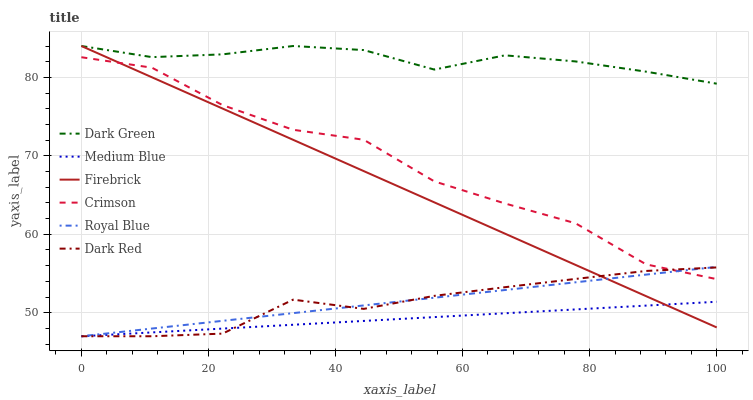Does Medium Blue have the minimum area under the curve?
Answer yes or no. Yes. Does Dark Green have the maximum area under the curve?
Answer yes or no. Yes. Does Firebrick have the minimum area under the curve?
Answer yes or no. No. Does Firebrick have the maximum area under the curve?
Answer yes or no. No. Is Firebrick the smoothest?
Answer yes or no. Yes. Is Crimson the roughest?
Answer yes or no. Yes. Is Medium Blue the smoothest?
Answer yes or no. No. Is Medium Blue the roughest?
Answer yes or no. No. Does Dark Red have the lowest value?
Answer yes or no. Yes. Does Firebrick have the lowest value?
Answer yes or no. No. Does Dark Green have the highest value?
Answer yes or no. Yes. Does Medium Blue have the highest value?
Answer yes or no. No. Is Medium Blue less than Crimson?
Answer yes or no. Yes. Is Dark Green greater than Crimson?
Answer yes or no. Yes. Does Dark Red intersect Crimson?
Answer yes or no. Yes. Is Dark Red less than Crimson?
Answer yes or no. No. Is Dark Red greater than Crimson?
Answer yes or no. No. Does Medium Blue intersect Crimson?
Answer yes or no. No. 